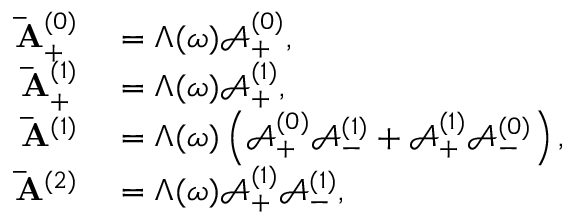<formula> <loc_0><loc_0><loc_500><loc_500>\begin{array} { r l } { \bar { A } _ { + } ^ { ( 0 ) } } & = \Lambda ( \omega ) \mathcal { A } _ { + } ^ { ( 0 ) } , } \\ { \bar { A } _ { + } ^ { ( 1 ) } } & = \Lambda ( \omega ) \mathcal { A } _ { + } ^ { ( 1 ) } , } \\ { \bar { A } ^ { ( 1 ) } } & = \Lambda ( \omega ) \left ( \mathcal { A } _ { + } ^ { ( 0 ) } \mathcal { A } _ { - } ^ { ( 1 ) } + \mathcal { A } _ { + } ^ { ( 1 ) } \mathcal { A } _ { - } ^ { ( 0 ) } \right ) , } \\ { \bar { A } ^ { ( 2 ) } } & = \Lambda ( \omega ) \mathcal { A } _ { + } ^ { ( 1 ) } \mathcal { A } _ { - } ^ { ( 1 ) } , } \end{array}</formula> 